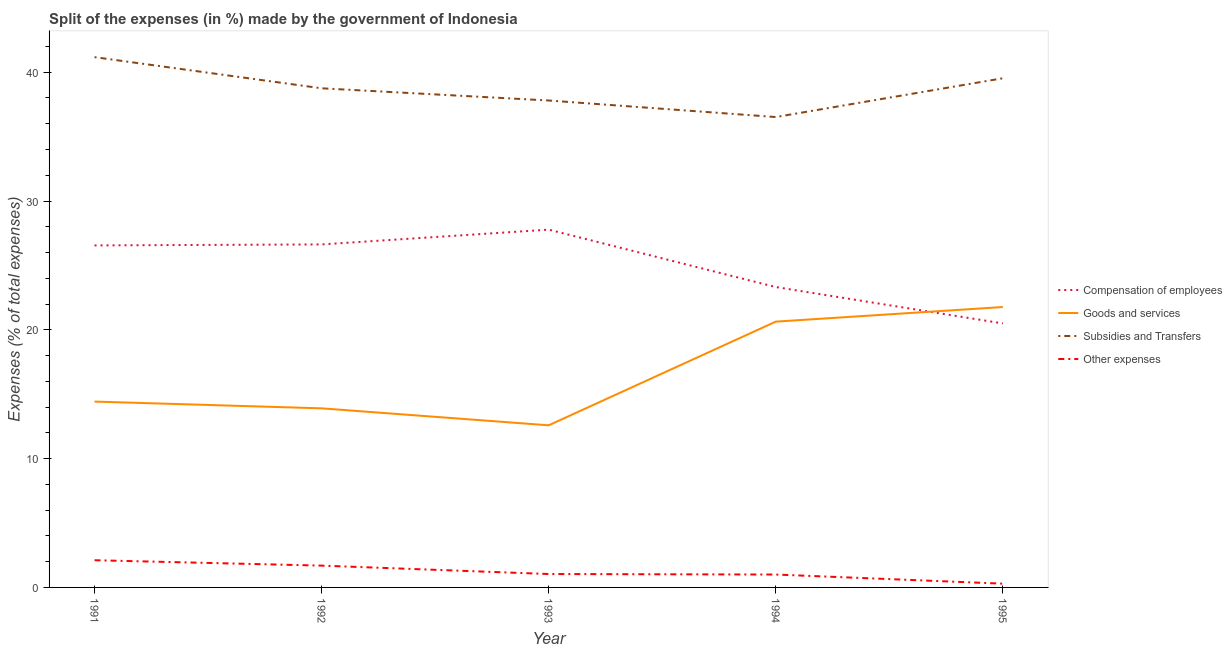How many different coloured lines are there?
Offer a terse response. 4. What is the percentage of amount spent on goods and services in 1995?
Make the answer very short. 21.77. Across all years, what is the maximum percentage of amount spent on subsidies?
Your answer should be very brief. 41.17. Across all years, what is the minimum percentage of amount spent on goods and services?
Make the answer very short. 12.59. In which year was the percentage of amount spent on goods and services maximum?
Your answer should be very brief. 1995. In which year was the percentage of amount spent on other expenses minimum?
Make the answer very short. 1995. What is the total percentage of amount spent on goods and services in the graph?
Offer a very short reply. 83.33. What is the difference between the percentage of amount spent on other expenses in 1993 and that in 1994?
Your answer should be very brief. 0.04. What is the difference between the percentage of amount spent on compensation of employees in 1993 and the percentage of amount spent on goods and services in 1991?
Offer a terse response. 13.35. What is the average percentage of amount spent on goods and services per year?
Offer a terse response. 16.67. In the year 1991, what is the difference between the percentage of amount spent on subsidies and percentage of amount spent on goods and services?
Keep it short and to the point. 26.74. In how many years, is the percentage of amount spent on subsidies greater than 36 %?
Offer a very short reply. 5. What is the ratio of the percentage of amount spent on other expenses in 1991 to that in 1995?
Your answer should be very brief. 7.23. Is the percentage of amount spent on goods and services in 1991 less than that in 1993?
Make the answer very short. No. Is the difference between the percentage of amount spent on subsidies in 1992 and 1994 greater than the difference between the percentage of amount spent on compensation of employees in 1992 and 1994?
Ensure brevity in your answer.  No. What is the difference between the highest and the second highest percentage of amount spent on goods and services?
Provide a short and direct response. 1.13. What is the difference between the highest and the lowest percentage of amount spent on other expenses?
Make the answer very short. 1.82. Is the percentage of amount spent on compensation of employees strictly less than the percentage of amount spent on goods and services over the years?
Your answer should be very brief. No. How many lines are there?
Make the answer very short. 4. How many years are there in the graph?
Offer a very short reply. 5. What is the difference between two consecutive major ticks on the Y-axis?
Ensure brevity in your answer.  10. Are the values on the major ticks of Y-axis written in scientific E-notation?
Your response must be concise. No. Does the graph contain grids?
Your response must be concise. No. Where does the legend appear in the graph?
Your answer should be compact. Center right. What is the title of the graph?
Provide a succinct answer. Split of the expenses (in %) made by the government of Indonesia. Does "Austria" appear as one of the legend labels in the graph?
Make the answer very short. No. What is the label or title of the Y-axis?
Offer a terse response. Expenses (% of total expenses). What is the Expenses (% of total expenses) of Compensation of employees in 1991?
Give a very brief answer. 26.55. What is the Expenses (% of total expenses) of Goods and services in 1991?
Offer a very short reply. 14.43. What is the Expenses (% of total expenses) in Subsidies and Transfers in 1991?
Ensure brevity in your answer.  41.17. What is the Expenses (% of total expenses) in Other expenses in 1991?
Ensure brevity in your answer.  2.11. What is the Expenses (% of total expenses) in Compensation of employees in 1992?
Your response must be concise. 26.63. What is the Expenses (% of total expenses) of Goods and services in 1992?
Your answer should be compact. 13.9. What is the Expenses (% of total expenses) in Subsidies and Transfers in 1992?
Your answer should be compact. 38.75. What is the Expenses (% of total expenses) of Other expenses in 1992?
Give a very brief answer. 1.69. What is the Expenses (% of total expenses) of Compensation of employees in 1993?
Your answer should be very brief. 27.78. What is the Expenses (% of total expenses) of Goods and services in 1993?
Keep it short and to the point. 12.59. What is the Expenses (% of total expenses) in Subsidies and Transfers in 1993?
Offer a very short reply. 37.8. What is the Expenses (% of total expenses) of Other expenses in 1993?
Provide a succinct answer. 1.04. What is the Expenses (% of total expenses) in Compensation of employees in 1994?
Provide a succinct answer. 23.32. What is the Expenses (% of total expenses) of Goods and services in 1994?
Your response must be concise. 20.64. What is the Expenses (% of total expenses) of Subsidies and Transfers in 1994?
Keep it short and to the point. 36.52. What is the Expenses (% of total expenses) of Other expenses in 1994?
Your answer should be very brief. 1. What is the Expenses (% of total expenses) of Compensation of employees in 1995?
Keep it short and to the point. 20.5. What is the Expenses (% of total expenses) of Goods and services in 1995?
Provide a succinct answer. 21.77. What is the Expenses (% of total expenses) in Subsidies and Transfers in 1995?
Your answer should be compact. 39.53. What is the Expenses (% of total expenses) of Other expenses in 1995?
Your answer should be compact. 0.29. Across all years, what is the maximum Expenses (% of total expenses) of Compensation of employees?
Provide a succinct answer. 27.78. Across all years, what is the maximum Expenses (% of total expenses) of Goods and services?
Ensure brevity in your answer.  21.77. Across all years, what is the maximum Expenses (% of total expenses) in Subsidies and Transfers?
Your response must be concise. 41.17. Across all years, what is the maximum Expenses (% of total expenses) in Other expenses?
Provide a succinct answer. 2.11. Across all years, what is the minimum Expenses (% of total expenses) of Compensation of employees?
Make the answer very short. 20.5. Across all years, what is the minimum Expenses (% of total expenses) of Goods and services?
Offer a very short reply. 12.59. Across all years, what is the minimum Expenses (% of total expenses) of Subsidies and Transfers?
Your answer should be compact. 36.52. Across all years, what is the minimum Expenses (% of total expenses) in Other expenses?
Keep it short and to the point. 0.29. What is the total Expenses (% of total expenses) of Compensation of employees in the graph?
Offer a very short reply. 124.78. What is the total Expenses (% of total expenses) of Goods and services in the graph?
Provide a short and direct response. 83.33. What is the total Expenses (% of total expenses) in Subsidies and Transfers in the graph?
Give a very brief answer. 193.78. What is the total Expenses (% of total expenses) of Other expenses in the graph?
Your answer should be compact. 6.14. What is the difference between the Expenses (% of total expenses) in Compensation of employees in 1991 and that in 1992?
Provide a succinct answer. -0.08. What is the difference between the Expenses (% of total expenses) in Goods and services in 1991 and that in 1992?
Offer a terse response. 0.52. What is the difference between the Expenses (% of total expenses) in Subsidies and Transfers in 1991 and that in 1992?
Your answer should be compact. 2.42. What is the difference between the Expenses (% of total expenses) of Other expenses in 1991 and that in 1992?
Give a very brief answer. 0.42. What is the difference between the Expenses (% of total expenses) in Compensation of employees in 1991 and that in 1993?
Offer a very short reply. -1.23. What is the difference between the Expenses (% of total expenses) of Goods and services in 1991 and that in 1993?
Give a very brief answer. 1.84. What is the difference between the Expenses (% of total expenses) in Subsidies and Transfers in 1991 and that in 1993?
Make the answer very short. 3.37. What is the difference between the Expenses (% of total expenses) of Other expenses in 1991 and that in 1993?
Make the answer very short. 1.07. What is the difference between the Expenses (% of total expenses) of Compensation of employees in 1991 and that in 1994?
Offer a very short reply. 3.23. What is the difference between the Expenses (% of total expenses) of Goods and services in 1991 and that in 1994?
Your answer should be compact. -6.21. What is the difference between the Expenses (% of total expenses) in Subsidies and Transfers in 1991 and that in 1994?
Make the answer very short. 4.65. What is the difference between the Expenses (% of total expenses) in Other expenses in 1991 and that in 1994?
Your response must be concise. 1.11. What is the difference between the Expenses (% of total expenses) of Compensation of employees in 1991 and that in 1995?
Your answer should be very brief. 6.06. What is the difference between the Expenses (% of total expenses) of Goods and services in 1991 and that in 1995?
Provide a succinct answer. -7.34. What is the difference between the Expenses (% of total expenses) of Subsidies and Transfers in 1991 and that in 1995?
Keep it short and to the point. 1.64. What is the difference between the Expenses (% of total expenses) in Other expenses in 1991 and that in 1995?
Offer a terse response. 1.82. What is the difference between the Expenses (% of total expenses) in Compensation of employees in 1992 and that in 1993?
Make the answer very short. -1.15. What is the difference between the Expenses (% of total expenses) of Goods and services in 1992 and that in 1993?
Provide a succinct answer. 1.32. What is the difference between the Expenses (% of total expenses) of Subsidies and Transfers in 1992 and that in 1993?
Offer a terse response. 0.95. What is the difference between the Expenses (% of total expenses) in Other expenses in 1992 and that in 1993?
Keep it short and to the point. 0.65. What is the difference between the Expenses (% of total expenses) in Compensation of employees in 1992 and that in 1994?
Your answer should be very brief. 3.31. What is the difference between the Expenses (% of total expenses) in Goods and services in 1992 and that in 1994?
Make the answer very short. -6.73. What is the difference between the Expenses (% of total expenses) of Subsidies and Transfers in 1992 and that in 1994?
Your answer should be very brief. 2.23. What is the difference between the Expenses (% of total expenses) of Other expenses in 1992 and that in 1994?
Your answer should be compact. 0.69. What is the difference between the Expenses (% of total expenses) in Compensation of employees in 1992 and that in 1995?
Your response must be concise. 6.13. What is the difference between the Expenses (% of total expenses) of Goods and services in 1992 and that in 1995?
Your response must be concise. -7.87. What is the difference between the Expenses (% of total expenses) of Subsidies and Transfers in 1992 and that in 1995?
Provide a short and direct response. -0.78. What is the difference between the Expenses (% of total expenses) of Other expenses in 1992 and that in 1995?
Give a very brief answer. 1.4. What is the difference between the Expenses (% of total expenses) in Compensation of employees in 1993 and that in 1994?
Ensure brevity in your answer.  4.46. What is the difference between the Expenses (% of total expenses) of Goods and services in 1993 and that in 1994?
Offer a terse response. -8.05. What is the difference between the Expenses (% of total expenses) in Subsidies and Transfers in 1993 and that in 1994?
Your answer should be very brief. 1.28. What is the difference between the Expenses (% of total expenses) of Other expenses in 1993 and that in 1994?
Make the answer very short. 0.04. What is the difference between the Expenses (% of total expenses) of Compensation of employees in 1993 and that in 1995?
Ensure brevity in your answer.  7.28. What is the difference between the Expenses (% of total expenses) of Goods and services in 1993 and that in 1995?
Ensure brevity in your answer.  -9.18. What is the difference between the Expenses (% of total expenses) in Subsidies and Transfers in 1993 and that in 1995?
Give a very brief answer. -1.73. What is the difference between the Expenses (% of total expenses) of Other expenses in 1993 and that in 1995?
Make the answer very short. 0.75. What is the difference between the Expenses (% of total expenses) in Compensation of employees in 1994 and that in 1995?
Your answer should be very brief. 2.83. What is the difference between the Expenses (% of total expenses) in Goods and services in 1994 and that in 1995?
Ensure brevity in your answer.  -1.13. What is the difference between the Expenses (% of total expenses) of Subsidies and Transfers in 1994 and that in 1995?
Give a very brief answer. -3.01. What is the difference between the Expenses (% of total expenses) of Other expenses in 1994 and that in 1995?
Offer a terse response. 0.71. What is the difference between the Expenses (% of total expenses) of Compensation of employees in 1991 and the Expenses (% of total expenses) of Goods and services in 1992?
Keep it short and to the point. 12.65. What is the difference between the Expenses (% of total expenses) of Compensation of employees in 1991 and the Expenses (% of total expenses) of Subsidies and Transfers in 1992?
Offer a very short reply. -12.2. What is the difference between the Expenses (% of total expenses) in Compensation of employees in 1991 and the Expenses (% of total expenses) in Other expenses in 1992?
Ensure brevity in your answer.  24.86. What is the difference between the Expenses (% of total expenses) of Goods and services in 1991 and the Expenses (% of total expenses) of Subsidies and Transfers in 1992?
Provide a succinct answer. -24.32. What is the difference between the Expenses (% of total expenses) in Goods and services in 1991 and the Expenses (% of total expenses) in Other expenses in 1992?
Offer a very short reply. 12.74. What is the difference between the Expenses (% of total expenses) of Subsidies and Transfers in 1991 and the Expenses (% of total expenses) of Other expenses in 1992?
Your answer should be very brief. 39.48. What is the difference between the Expenses (% of total expenses) in Compensation of employees in 1991 and the Expenses (% of total expenses) in Goods and services in 1993?
Your answer should be compact. 13.97. What is the difference between the Expenses (% of total expenses) of Compensation of employees in 1991 and the Expenses (% of total expenses) of Subsidies and Transfers in 1993?
Offer a very short reply. -11.25. What is the difference between the Expenses (% of total expenses) of Compensation of employees in 1991 and the Expenses (% of total expenses) of Other expenses in 1993?
Provide a succinct answer. 25.51. What is the difference between the Expenses (% of total expenses) of Goods and services in 1991 and the Expenses (% of total expenses) of Subsidies and Transfers in 1993?
Give a very brief answer. -23.38. What is the difference between the Expenses (% of total expenses) of Goods and services in 1991 and the Expenses (% of total expenses) of Other expenses in 1993?
Give a very brief answer. 13.39. What is the difference between the Expenses (% of total expenses) of Subsidies and Transfers in 1991 and the Expenses (% of total expenses) of Other expenses in 1993?
Your answer should be very brief. 40.13. What is the difference between the Expenses (% of total expenses) of Compensation of employees in 1991 and the Expenses (% of total expenses) of Goods and services in 1994?
Offer a terse response. 5.92. What is the difference between the Expenses (% of total expenses) of Compensation of employees in 1991 and the Expenses (% of total expenses) of Subsidies and Transfers in 1994?
Provide a short and direct response. -9.97. What is the difference between the Expenses (% of total expenses) of Compensation of employees in 1991 and the Expenses (% of total expenses) of Other expenses in 1994?
Your response must be concise. 25.55. What is the difference between the Expenses (% of total expenses) in Goods and services in 1991 and the Expenses (% of total expenses) in Subsidies and Transfers in 1994?
Your response must be concise. -22.09. What is the difference between the Expenses (% of total expenses) of Goods and services in 1991 and the Expenses (% of total expenses) of Other expenses in 1994?
Your answer should be compact. 13.43. What is the difference between the Expenses (% of total expenses) of Subsidies and Transfers in 1991 and the Expenses (% of total expenses) of Other expenses in 1994?
Your answer should be compact. 40.17. What is the difference between the Expenses (% of total expenses) in Compensation of employees in 1991 and the Expenses (% of total expenses) in Goods and services in 1995?
Give a very brief answer. 4.78. What is the difference between the Expenses (% of total expenses) of Compensation of employees in 1991 and the Expenses (% of total expenses) of Subsidies and Transfers in 1995?
Keep it short and to the point. -12.98. What is the difference between the Expenses (% of total expenses) in Compensation of employees in 1991 and the Expenses (% of total expenses) in Other expenses in 1995?
Keep it short and to the point. 26.26. What is the difference between the Expenses (% of total expenses) in Goods and services in 1991 and the Expenses (% of total expenses) in Subsidies and Transfers in 1995?
Make the answer very short. -25.1. What is the difference between the Expenses (% of total expenses) in Goods and services in 1991 and the Expenses (% of total expenses) in Other expenses in 1995?
Keep it short and to the point. 14.14. What is the difference between the Expenses (% of total expenses) in Subsidies and Transfers in 1991 and the Expenses (% of total expenses) in Other expenses in 1995?
Give a very brief answer. 40.88. What is the difference between the Expenses (% of total expenses) in Compensation of employees in 1992 and the Expenses (% of total expenses) in Goods and services in 1993?
Give a very brief answer. 14.04. What is the difference between the Expenses (% of total expenses) in Compensation of employees in 1992 and the Expenses (% of total expenses) in Subsidies and Transfers in 1993?
Your answer should be compact. -11.17. What is the difference between the Expenses (% of total expenses) of Compensation of employees in 1992 and the Expenses (% of total expenses) of Other expenses in 1993?
Your response must be concise. 25.59. What is the difference between the Expenses (% of total expenses) of Goods and services in 1992 and the Expenses (% of total expenses) of Subsidies and Transfers in 1993?
Offer a terse response. -23.9. What is the difference between the Expenses (% of total expenses) of Goods and services in 1992 and the Expenses (% of total expenses) of Other expenses in 1993?
Your response must be concise. 12.86. What is the difference between the Expenses (% of total expenses) in Subsidies and Transfers in 1992 and the Expenses (% of total expenses) in Other expenses in 1993?
Keep it short and to the point. 37.71. What is the difference between the Expenses (% of total expenses) of Compensation of employees in 1992 and the Expenses (% of total expenses) of Goods and services in 1994?
Provide a succinct answer. 5.99. What is the difference between the Expenses (% of total expenses) in Compensation of employees in 1992 and the Expenses (% of total expenses) in Subsidies and Transfers in 1994?
Offer a very short reply. -9.89. What is the difference between the Expenses (% of total expenses) in Compensation of employees in 1992 and the Expenses (% of total expenses) in Other expenses in 1994?
Provide a succinct answer. 25.63. What is the difference between the Expenses (% of total expenses) of Goods and services in 1992 and the Expenses (% of total expenses) of Subsidies and Transfers in 1994?
Provide a succinct answer. -22.62. What is the difference between the Expenses (% of total expenses) in Goods and services in 1992 and the Expenses (% of total expenses) in Other expenses in 1994?
Offer a terse response. 12.9. What is the difference between the Expenses (% of total expenses) in Subsidies and Transfers in 1992 and the Expenses (% of total expenses) in Other expenses in 1994?
Give a very brief answer. 37.75. What is the difference between the Expenses (% of total expenses) in Compensation of employees in 1992 and the Expenses (% of total expenses) in Goods and services in 1995?
Provide a short and direct response. 4.86. What is the difference between the Expenses (% of total expenses) in Compensation of employees in 1992 and the Expenses (% of total expenses) in Subsidies and Transfers in 1995?
Keep it short and to the point. -12.9. What is the difference between the Expenses (% of total expenses) of Compensation of employees in 1992 and the Expenses (% of total expenses) of Other expenses in 1995?
Give a very brief answer. 26.34. What is the difference between the Expenses (% of total expenses) in Goods and services in 1992 and the Expenses (% of total expenses) in Subsidies and Transfers in 1995?
Your answer should be compact. -25.63. What is the difference between the Expenses (% of total expenses) of Goods and services in 1992 and the Expenses (% of total expenses) of Other expenses in 1995?
Offer a very short reply. 13.61. What is the difference between the Expenses (% of total expenses) in Subsidies and Transfers in 1992 and the Expenses (% of total expenses) in Other expenses in 1995?
Provide a short and direct response. 38.46. What is the difference between the Expenses (% of total expenses) of Compensation of employees in 1993 and the Expenses (% of total expenses) of Goods and services in 1994?
Keep it short and to the point. 7.14. What is the difference between the Expenses (% of total expenses) in Compensation of employees in 1993 and the Expenses (% of total expenses) in Subsidies and Transfers in 1994?
Provide a short and direct response. -8.74. What is the difference between the Expenses (% of total expenses) in Compensation of employees in 1993 and the Expenses (% of total expenses) in Other expenses in 1994?
Your answer should be compact. 26.78. What is the difference between the Expenses (% of total expenses) of Goods and services in 1993 and the Expenses (% of total expenses) of Subsidies and Transfers in 1994?
Offer a terse response. -23.93. What is the difference between the Expenses (% of total expenses) of Goods and services in 1993 and the Expenses (% of total expenses) of Other expenses in 1994?
Offer a very short reply. 11.59. What is the difference between the Expenses (% of total expenses) of Subsidies and Transfers in 1993 and the Expenses (% of total expenses) of Other expenses in 1994?
Keep it short and to the point. 36.8. What is the difference between the Expenses (% of total expenses) of Compensation of employees in 1993 and the Expenses (% of total expenses) of Goods and services in 1995?
Offer a very short reply. 6.01. What is the difference between the Expenses (% of total expenses) of Compensation of employees in 1993 and the Expenses (% of total expenses) of Subsidies and Transfers in 1995?
Provide a succinct answer. -11.75. What is the difference between the Expenses (% of total expenses) in Compensation of employees in 1993 and the Expenses (% of total expenses) in Other expenses in 1995?
Your response must be concise. 27.49. What is the difference between the Expenses (% of total expenses) of Goods and services in 1993 and the Expenses (% of total expenses) of Subsidies and Transfers in 1995?
Offer a terse response. -26.94. What is the difference between the Expenses (% of total expenses) in Goods and services in 1993 and the Expenses (% of total expenses) in Other expenses in 1995?
Your answer should be compact. 12.29. What is the difference between the Expenses (% of total expenses) in Subsidies and Transfers in 1993 and the Expenses (% of total expenses) in Other expenses in 1995?
Offer a terse response. 37.51. What is the difference between the Expenses (% of total expenses) in Compensation of employees in 1994 and the Expenses (% of total expenses) in Goods and services in 1995?
Give a very brief answer. 1.55. What is the difference between the Expenses (% of total expenses) in Compensation of employees in 1994 and the Expenses (% of total expenses) in Subsidies and Transfers in 1995?
Keep it short and to the point. -16.21. What is the difference between the Expenses (% of total expenses) of Compensation of employees in 1994 and the Expenses (% of total expenses) of Other expenses in 1995?
Offer a very short reply. 23.03. What is the difference between the Expenses (% of total expenses) in Goods and services in 1994 and the Expenses (% of total expenses) in Subsidies and Transfers in 1995?
Provide a short and direct response. -18.89. What is the difference between the Expenses (% of total expenses) in Goods and services in 1994 and the Expenses (% of total expenses) in Other expenses in 1995?
Give a very brief answer. 20.34. What is the difference between the Expenses (% of total expenses) in Subsidies and Transfers in 1994 and the Expenses (% of total expenses) in Other expenses in 1995?
Provide a succinct answer. 36.23. What is the average Expenses (% of total expenses) of Compensation of employees per year?
Provide a short and direct response. 24.96. What is the average Expenses (% of total expenses) of Goods and services per year?
Provide a succinct answer. 16.67. What is the average Expenses (% of total expenses) of Subsidies and Transfers per year?
Ensure brevity in your answer.  38.76. What is the average Expenses (% of total expenses) in Other expenses per year?
Your response must be concise. 1.23. In the year 1991, what is the difference between the Expenses (% of total expenses) in Compensation of employees and Expenses (% of total expenses) in Goods and services?
Your answer should be compact. 12.12. In the year 1991, what is the difference between the Expenses (% of total expenses) of Compensation of employees and Expenses (% of total expenses) of Subsidies and Transfers?
Ensure brevity in your answer.  -14.62. In the year 1991, what is the difference between the Expenses (% of total expenses) of Compensation of employees and Expenses (% of total expenses) of Other expenses?
Make the answer very short. 24.44. In the year 1991, what is the difference between the Expenses (% of total expenses) in Goods and services and Expenses (% of total expenses) in Subsidies and Transfers?
Offer a terse response. -26.74. In the year 1991, what is the difference between the Expenses (% of total expenses) of Goods and services and Expenses (% of total expenses) of Other expenses?
Your answer should be compact. 12.32. In the year 1991, what is the difference between the Expenses (% of total expenses) of Subsidies and Transfers and Expenses (% of total expenses) of Other expenses?
Keep it short and to the point. 39.06. In the year 1992, what is the difference between the Expenses (% of total expenses) of Compensation of employees and Expenses (% of total expenses) of Goods and services?
Ensure brevity in your answer.  12.73. In the year 1992, what is the difference between the Expenses (% of total expenses) of Compensation of employees and Expenses (% of total expenses) of Subsidies and Transfers?
Provide a short and direct response. -12.12. In the year 1992, what is the difference between the Expenses (% of total expenses) in Compensation of employees and Expenses (% of total expenses) in Other expenses?
Your answer should be very brief. 24.94. In the year 1992, what is the difference between the Expenses (% of total expenses) of Goods and services and Expenses (% of total expenses) of Subsidies and Transfers?
Your answer should be compact. -24.85. In the year 1992, what is the difference between the Expenses (% of total expenses) in Goods and services and Expenses (% of total expenses) in Other expenses?
Provide a short and direct response. 12.21. In the year 1992, what is the difference between the Expenses (% of total expenses) in Subsidies and Transfers and Expenses (% of total expenses) in Other expenses?
Offer a terse response. 37.06. In the year 1993, what is the difference between the Expenses (% of total expenses) in Compensation of employees and Expenses (% of total expenses) in Goods and services?
Provide a short and direct response. 15.19. In the year 1993, what is the difference between the Expenses (% of total expenses) of Compensation of employees and Expenses (% of total expenses) of Subsidies and Transfers?
Give a very brief answer. -10.03. In the year 1993, what is the difference between the Expenses (% of total expenses) of Compensation of employees and Expenses (% of total expenses) of Other expenses?
Keep it short and to the point. 26.74. In the year 1993, what is the difference between the Expenses (% of total expenses) of Goods and services and Expenses (% of total expenses) of Subsidies and Transfers?
Your answer should be very brief. -25.22. In the year 1993, what is the difference between the Expenses (% of total expenses) of Goods and services and Expenses (% of total expenses) of Other expenses?
Your answer should be compact. 11.55. In the year 1993, what is the difference between the Expenses (% of total expenses) of Subsidies and Transfers and Expenses (% of total expenses) of Other expenses?
Your answer should be very brief. 36.76. In the year 1994, what is the difference between the Expenses (% of total expenses) in Compensation of employees and Expenses (% of total expenses) in Goods and services?
Provide a short and direct response. 2.68. In the year 1994, what is the difference between the Expenses (% of total expenses) in Compensation of employees and Expenses (% of total expenses) in Subsidies and Transfers?
Your answer should be very brief. -13.2. In the year 1994, what is the difference between the Expenses (% of total expenses) in Compensation of employees and Expenses (% of total expenses) in Other expenses?
Your answer should be compact. 22.32. In the year 1994, what is the difference between the Expenses (% of total expenses) of Goods and services and Expenses (% of total expenses) of Subsidies and Transfers?
Ensure brevity in your answer.  -15.88. In the year 1994, what is the difference between the Expenses (% of total expenses) of Goods and services and Expenses (% of total expenses) of Other expenses?
Offer a very short reply. 19.64. In the year 1994, what is the difference between the Expenses (% of total expenses) in Subsidies and Transfers and Expenses (% of total expenses) in Other expenses?
Keep it short and to the point. 35.52. In the year 1995, what is the difference between the Expenses (% of total expenses) in Compensation of employees and Expenses (% of total expenses) in Goods and services?
Offer a terse response. -1.27. In the year 1995, what is the difference between the Expenses (% of total expenses) in Compensation of employees and Expenses (% of total expenses) in Subsidies and Transfers?
Your response must be concise. -19.03. In the year 1995, what is the difference between the Expenses (% of total expenses) of Compensation of employees and Expenses (% of total expenses) of Other expenses?
Provide a succinct answer. 20.2. In the year 1995, what is the difference between the Expenses (% of total expenses) of Goods and services and Expenses (% of total expenses) of Subsidies and Transfers?
Your answer should be compact. -17.76. In the year 1995, what is the difference between the Expenses (% of total expenses) of Goods and services and Expenses (% of total expenses) of Other expenses?
Provide a short and direct response. 21.48. In the year 1995, what is the difference between the Expenses (% of total expenses) in Subsidies and Transfers and Expenses (% of total expenses) in Other expenses?
Your response must be concise. 39.24. What is the ratio of the Expenses (% of total expenses) of Compensation of employees in 1991 to that in 1992?
Make the answer very short. 1. What is the ratio of the Expenses (% of total expenses) in Goods and services in 1991 to that in 1992?
Make the answer very short. 1.04. What is the ratio of the Expenses (% of total expenses) of Subsidies and Transfers in 1991 to that in 1992?
Offer a terse response. 1.06. What is the ratio of the Expenses (% of total expenses) of Other expenses in 1991 to that in 1992?
Ensure brevity in your answer.  1.25. What is the ratio of the Expenses (% of total expenses) of Compensation of employees in 1991 to that in 1993?
Keep it short and to the point. 0.96. What is the ratio of the Expenses (% of total expenses) of Goods and services in 1991 to that in 1993?
Your answer should be very brief. 1.15. What is the ratio of the Expenses (% of total expenses) of Subsidies and Transfers in 1991 to that in 1993?
Ensure brevity in your answer.  1.09. What is the ratio of the Expenses (% of total expenses) of Other expenses in 1991 to that in 1993?
Provide a succinct answer. 2.03. What is the ratio of the Expenses (% of total expenses) of Compensation of employees in 1991 to that in 1994?
Ensure brevity in your answer.  1.14. What is the ratio of the Expenses (% of total expenses) in Goods and services in 1991 to that in 1994?
Your response must be concise. 0.7. What is the ratio of the Expenses (% of total expenses) in Subsidies and Transfers in 1991 to that in 1994?
Ensure brevity in your answer.  1.13. What is the ratio of the Expenses (% of total expenses) of Other expenses in 1991 to that in 1994?
Offer a very short reply. 2.11. What is the ratio of the Expenses (% of total expenses) in Compensation of employees in 1991 to that in 1995?
Ensure brevity in your answer.  1.3. What is the ratio of the Expenses (% of total expenses) in Goods and services in 1991 to that in 1995?
Offer a very short reply. 0.66. What is the ratio of the Expenses (% of total expenses) in Subsidies and Transfers in 1991 to that in 1995?
Give a very brief answer. 1.04. What is the ratio of the Expenses (% of total expenses) of Other expenses in 1991 to that in 1995?
Provide a succinct answer. 7.23. What is the ratio of the Expenses (% of total expenses) of Compensation of employees in 1992 to that in 1993?
Keep it short and to the point. 0.96. What is the ratio of the Expenses (% of total expenses) in Goods and services in 1992 to that in 1993?
Your response must be concise. 1.1. What is the ratio of the Expenses (% of total expenses) of Other expenses in 1992 to that in 1993?
Ensure brevity in your answer.  1.63. What is the ratio of the Expenses (% of total expenses) of Compensation of employees in 1992 to that in 1994?
Offer a very short reply. 1.14. What is the ratio of the Expenses (% of total expenses) of Goods and services in 1992 to that in 1994?
Keep it short and to the point. 0.67. What is the ratio of the Expenses (% of total expenses) in Subsidies and Transfers in 1992 to that in 1994?
Give a very brief answer. 1.06. What is the ratio of the Expenses (% of total expenses) of Other expenses in 1992 to that in 1994?
Provide a short and direct response. 1.69. What is the ratio of the Expenses (% of total expenses) of Compensation of employees in 1992 to that in 1995?
Ensure brevity in your answer.  1.3. What is the ratio of the Expenses (% of total expenses) in Goods and services in 1992 to that in 1995?
Make the answer very short. 0.64. What is the ratio of the Expenses (% of total expenses) of Subsidies and Transfers in 1992 to that in 1995?
Give a very brief answer. 0.98. What is the ratio of the Expenses (% of total expenses) of Other expenses in 1992 to that in 1995?
Offer a terse response. 5.79. What is the ratio of the Expenses (% of total expenses) of Compensation of employees in 1993 to that in 1994?
Provide a short and direct response. 1.19. What is the ratio of the Expenses (% of total expenses) of Goods and services in 1993 to that in 1994?
Ensure brevity in your answer.  0.61. What is the ratio of the Expenses (% of total expenses) of Subsidies and Transfers in 1993 to that in 1994?
Ensure brevity in your answer.  1.04. What is the ratio of the Expenses (% of total expenses) of Other expenses in 1993 to that in 1994?
Offer a very short reply. 1.04. What is the ratio of the Expenses (% of total expenses) in Compensation of employees in 1993 to that in 1995?
Offer a very short reply. 1.36. What is the ratio of the Expenses (% of total expenses) of Goods and services in 1993 to that in 1995?
Offer a very short reply. 0.58. What is the ratio of the Expenses (% of total expenses) in Subsidies and Transfers in 1993 to that in 1995?
Your answer should be very brief. 0.96. What is the ratio of the Expenses (% of total expenses) of Other expenses in 1993 to that in 1995?
Give a very brief answer. 3.56. What is the ratio of the Expenses (% of total expenses) in Compensation of employees in 1994 to that in 1995?
Ensure brevity in your answer.  1.14. What is the ratio of the Expenses (% of total expenses) of Goods and services in 1994 to that in 1995?
Provide a short and direct response. 0.95. What is the ratio of the Expenses (% of total expenses) of Subsidies and Transfers in 1994 to that in 1995?
Your response must be concise. 0.92. What is the ratio of the Expenses (% of total expenses) in Other expenses in 1994 to that in 1995?
Keep it short and to the point. 3.42. What is the difference between the highest and the second highest Expenses (% of total expenses) of Compensation of employees?
Provide a short and direct response. 1.15. What is the difference between the highest and the second highest Expenses (% of total expenses) of Goods and services?
Provide a succinct answer. 1.13. What is the difference between the highest and the second highest Expenses (% of total expenses) in Subsidies and Transfers?
Your answer should be compact. 1.64. What is the difference between the highest and the second highest Expenses (% of total expenses) in Other expenses?
Make the answer very short. 0.42. What is the difference between the highest and the lowest Expenses (% of total expenses) of Compensation of employees?
Your response must be concise. 7.28. What is the difference between the highest and the lowest Expenses (% of total expenses) of Goods and services?
Keep it short and to the point. 9.18. What is the difference between the highest and the lowest Expenses (% of total expenses) of Subsidies and Transfers?
Give a very brief answer. 4.65. What is the difference between the highest and the lowest Expenses (% of total expenses) of Other expenses?
Keep it short and to the point. 1.82. 